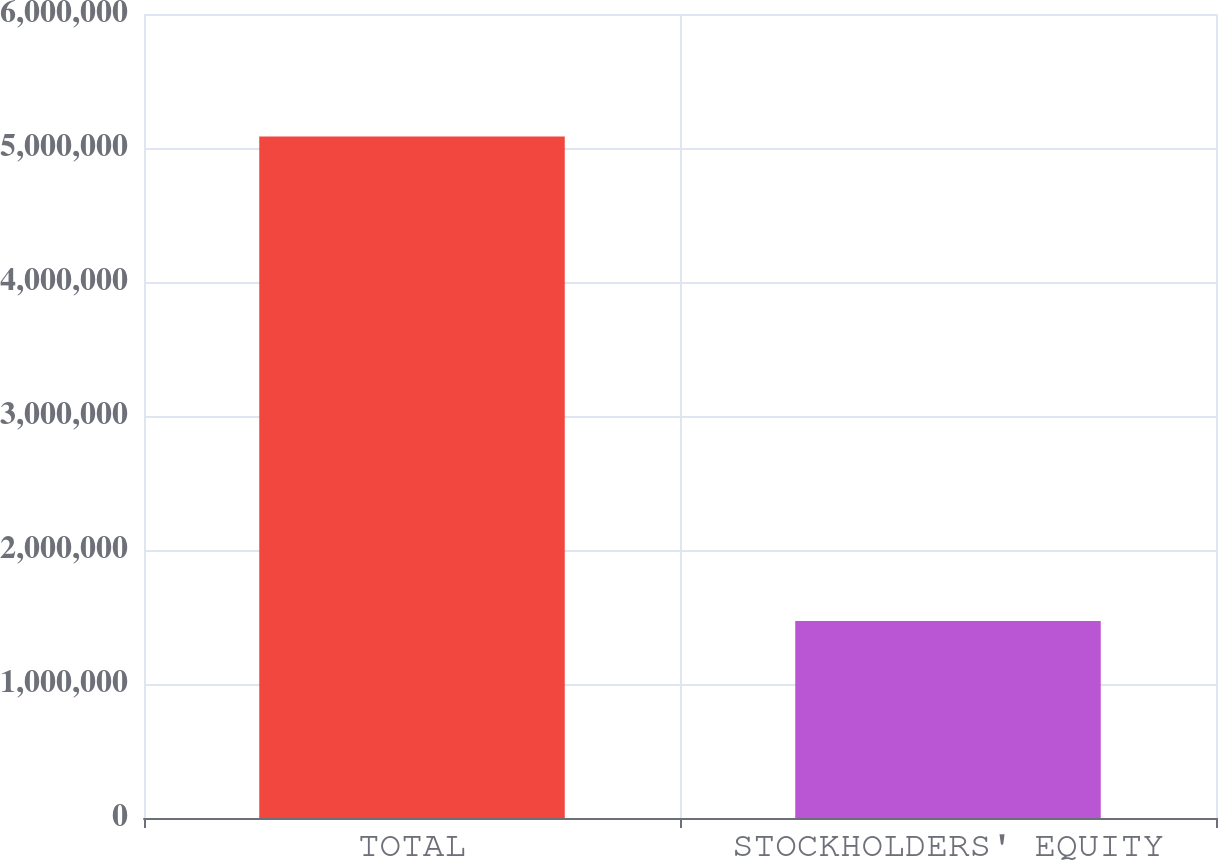<chart> <loc_0><loc_0><loc_500><loc_500><bar_chart><fcel>TOTAL<fcel>STOCKHOLDERS' EQUITY<nl><fcel>5.08597e+06<fcel>1.47095e+06<nl></chart> 